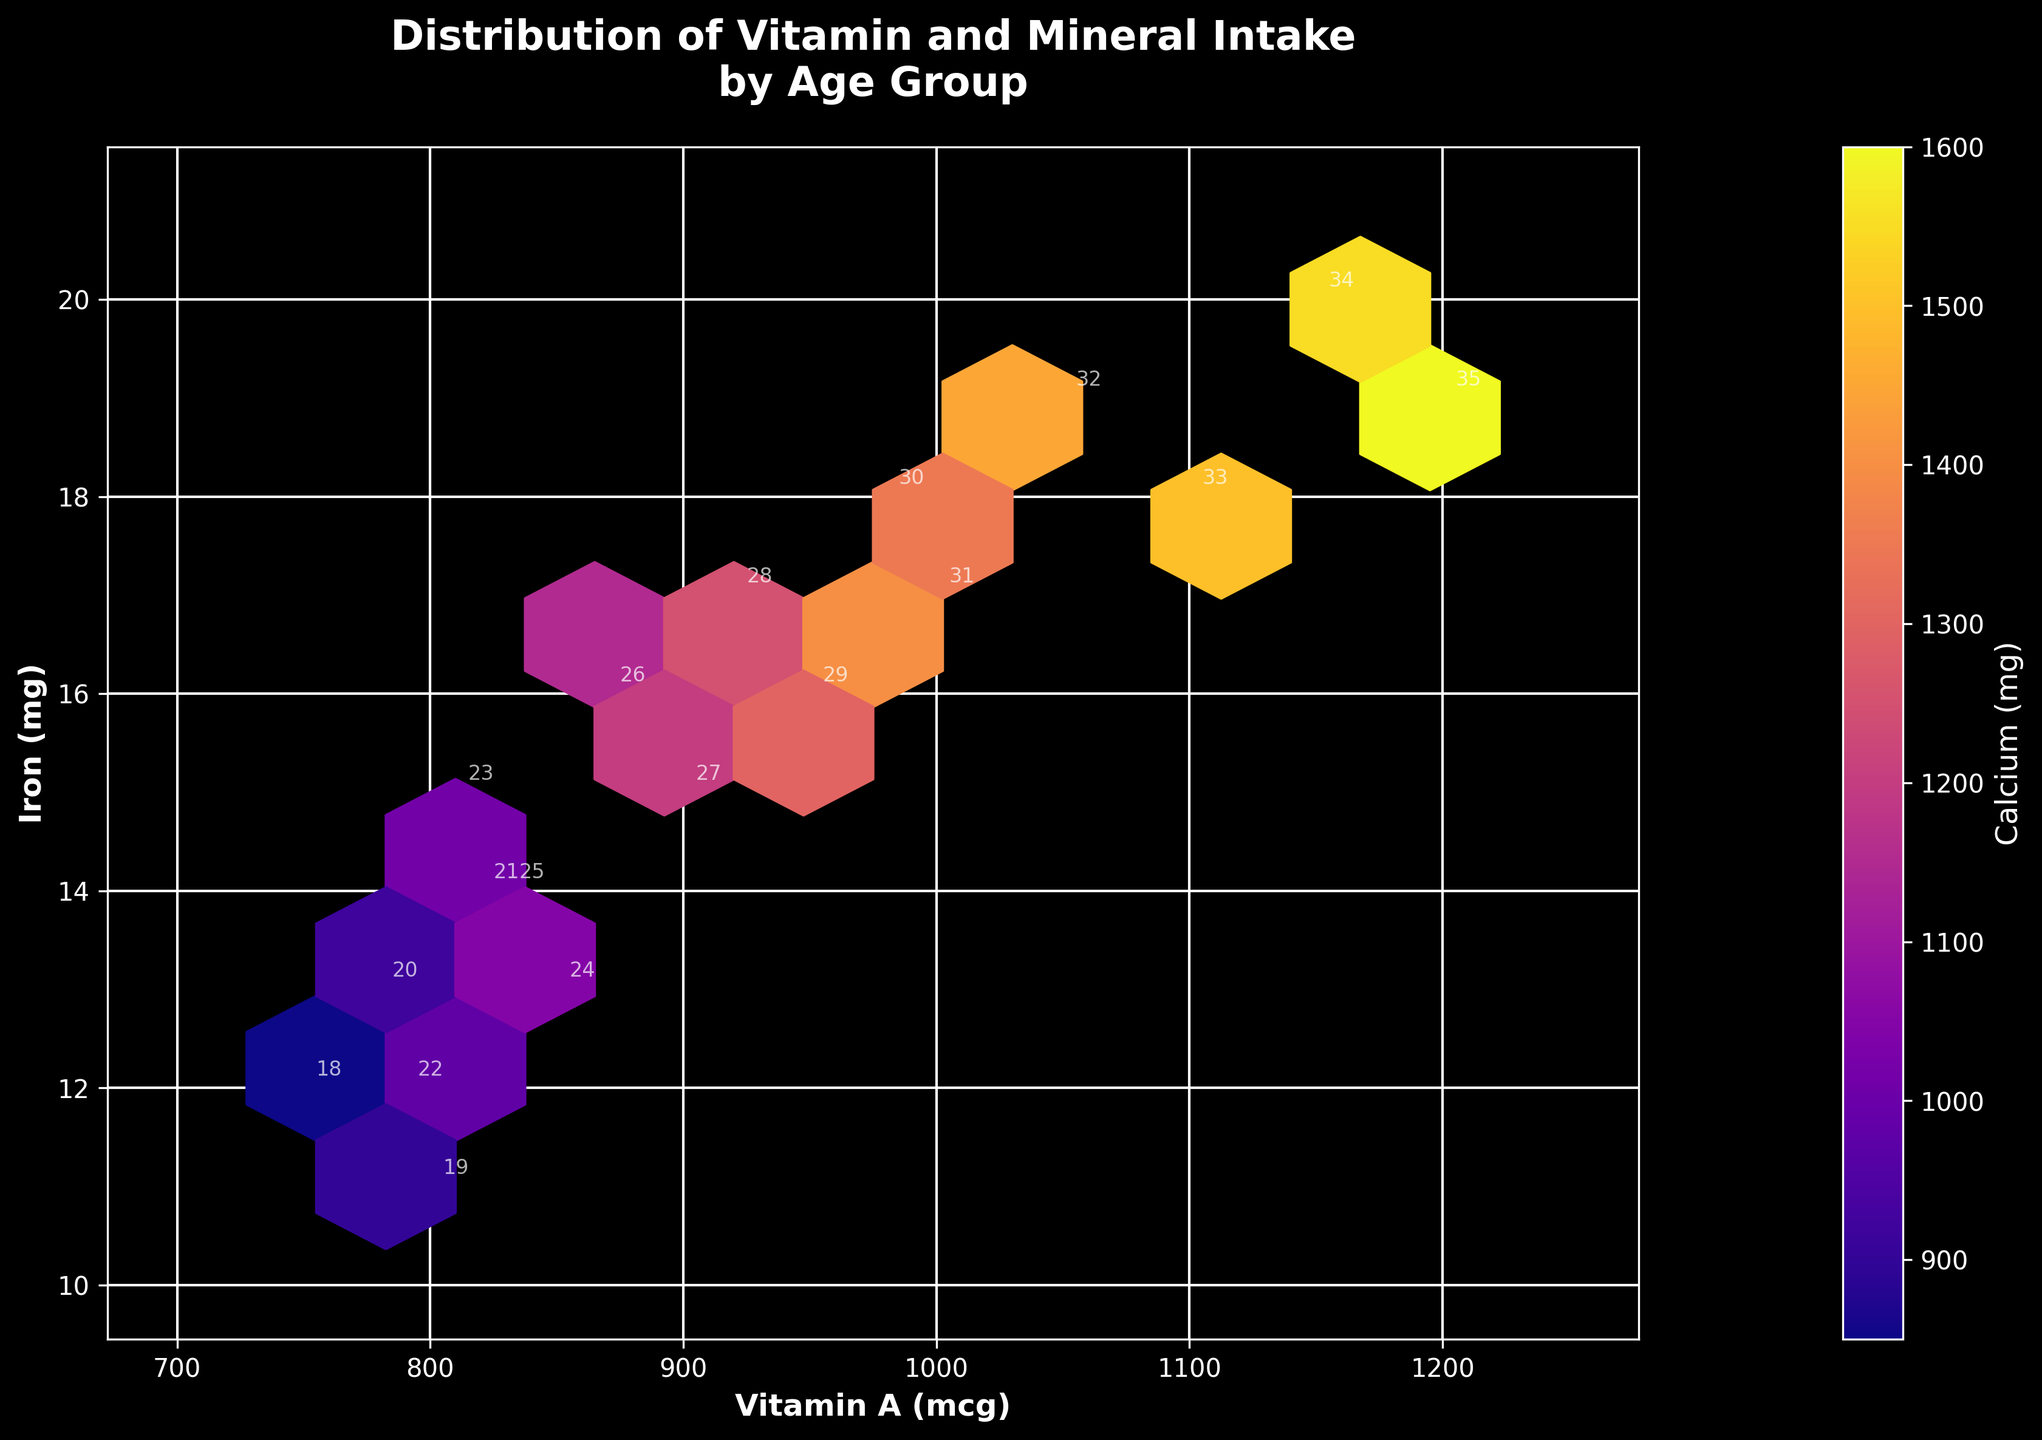What does the title of the plot say? The title is located at the top of the plot and provides a brief description of the plot's focus. In this case, it reads "Distribution of Vitamin and Mineral Intake by Age Group."
Answer: Distribution of Vitamin and Mineral Intake by Age Group What are the labels of the x-axis and y-axis? The x-axis label is found below the x-axis and the y-axis label is found to the left of the y-axis. Here, they are labeled "Vitamin A (mcg)" and "Iron (mg)," respectively.
Answer: Vitamin A (mcg) and Iron (mg) How many data points are labeled in the plot? By examining the annotated labels with white text, we can count the individual age values. Each age from 18 to 35 is labeled, meaning there are 18 data points.
Answer: 18 What is the color bar label and what does it represent? The color bar is on the right side of the plot and its label can be found next to it. It indicates "Calcium (mg)," representing the intensity of calcium intake in milligrams.
Answer: Calcium (mg) Which age group has the highest Calcium intake and what is its value? By looking at the color intensity linked to specific data points, age 35 (label 35) has the darkest shade, which indicates the highest Calcium intake. The Calcium intake is 1600 mg.
Answer: Age 35, 1600 mg What age group is associated with a Vitamin A intake of 800 mcg and Iron intake of 11 mg? By finding the data point where Vitamin A intake is 800 mcg and Iron intake is 11 mg, the age group label next to it is 19.
Answer: Age 19 What are the ranges of Vitamin A and Iron intake values used in the plot? Observing the axes, the x-axis (Vitamin A) ranges from 700 to 1250 mcg, and the y-axis (Iron) ranges from 10 to 21 mg.
Answer: 700 to 1250 mcg (Vitamin A) and 10 to 21 mg (Iron) In which range of Vitamin A intake do the most data points fall? By observing the x-axis and counting the number of hexagons (tiling) filled within specific intervals, most data points fall within the range of 900 to 1100 mcg of Vitamin A.
Answer: 900 to 1100 mcg Explain the correlation between Vitamin A and Iron intake observed in the plot. The dots form a somewhat consistent diagonal pattern, indicating a positive correlation. As the Vitamin A intake increases, the Iron intake also tends to increase.
Answer: Positive correlation Which age group has the highest Iron intake without being the highest in Calcium intake? Data points for Iron intake of 20 mg can be examined; age 34 stands out with the highest Iron intake. The Calcium intake of age 34 (1550 mg) is less than that of 35 (1600 mg) though higher in Iron.
Answer: Age 34 